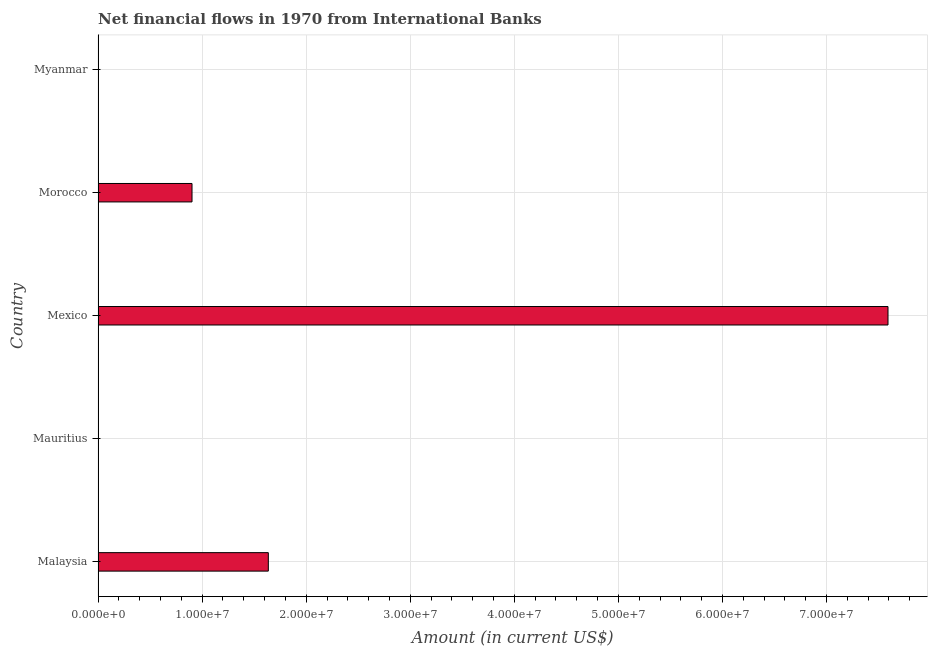What is the title of the graph?
Your answer should be compact. Net financial flows in 1970 from International Banks. What is the label or title of the X-axis?
Give a very brief answer. Amount (in current US$). What is the label or title of the Y-axis?
Provide a succinct answer. Country. What is the net financial flows from ibrd in Myanmar?
Make the answer very short. 0. Across all countries, what is the maximum net financial flows from ibrd?
Offer a very short reply. 7.59e+07. Across all countries, what is the minimum net financial flows from ibrd?
Make the answer very short. 0. What is the sum of the net financial flows from ibrd?
Your answer should be very brief. 1.01e+08. What is the difference between the net financial flows from ibrd in Mexico and Morocco?
Provide a succinct answer. 6.69e+07. What is the average net financial flows from ibrd per country?
Ensure brevity in your answer.  2.03e+07. What is the median net financial flows from ibrd?
Offer a very short reply. 9.03e+06. In how many countries, is the net financial flows from ibrd greater than 72000000 US$?
Give a very brief answer. 1. What is the ratio of the net financial flows from ibrd in Malaysia to that in Mexico?
Give a very brief answer. 0.22. Is the difference between the net financial flows from ibrd in Malaysia and Mexico greater than the difference between any two countries?
Your response must be concise. No. What is the difference between the highest and the second highest net financial flows from ibrd?
Provide a succinct answer. 5.95e+07. What is the difference between the highest and the lowest net financial flows from ibrd?
Ensure brevity in your answer.  7.59e+07. Are all the bars in the graph horizontal?
Your answer should be very brief. Yes. What is the difference between two consecutive major ticks on the X-axis?
Provide a succinct answer. 1.00e+07. What is the Amount (in current US$) in Malaysia?
Your answer should be compact. 1.64e+07. What is the Amount (in current US$) of Mauritius?
Keep it short and to the point. 0. What is the Amount (in current US$) in Mexico?
Offer a terse response. 7.59e+07. What is the Amount (in current US$) of Morocco?
Give a very brief answer. 9.03e+06. What is the difference between the Amount (in current US$) in Malaysia and Mexico?
Keep it short and to the point. -5.95e+07. What is the difference between the Amount (in current US$) in Malaysia and Morocco?
Offer a terse response. 7.33e+06. What is the difference between the Amount (in current US$) in Mexico and Morocco?
Your answer should be compact. 6.69e+07. What is the ratio of the Amount (in current US$) in Malaysia to that in Mexico?
Your answer should be compact. 0.22. What is the ratio of the Amount (in current US$) in Malaysia to that in Morocco?
Ensure brevity in your answer.  1.81. What is the ratio of the Amount (in current US$) in Mexico to that in Morocco?
Provide a succinct answer. 8.41. 